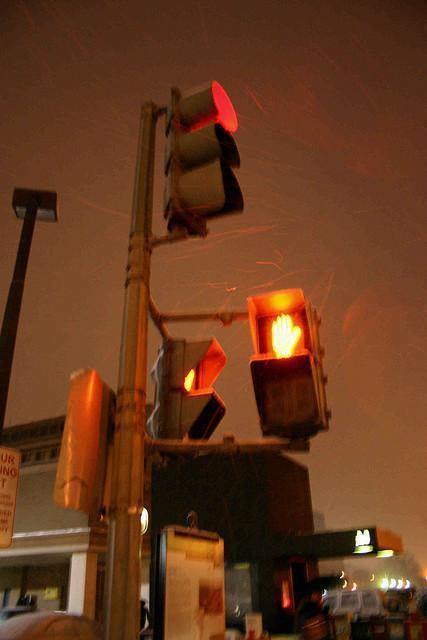How many traffic lights are in the photo?
Give a very brief answer. 3. 